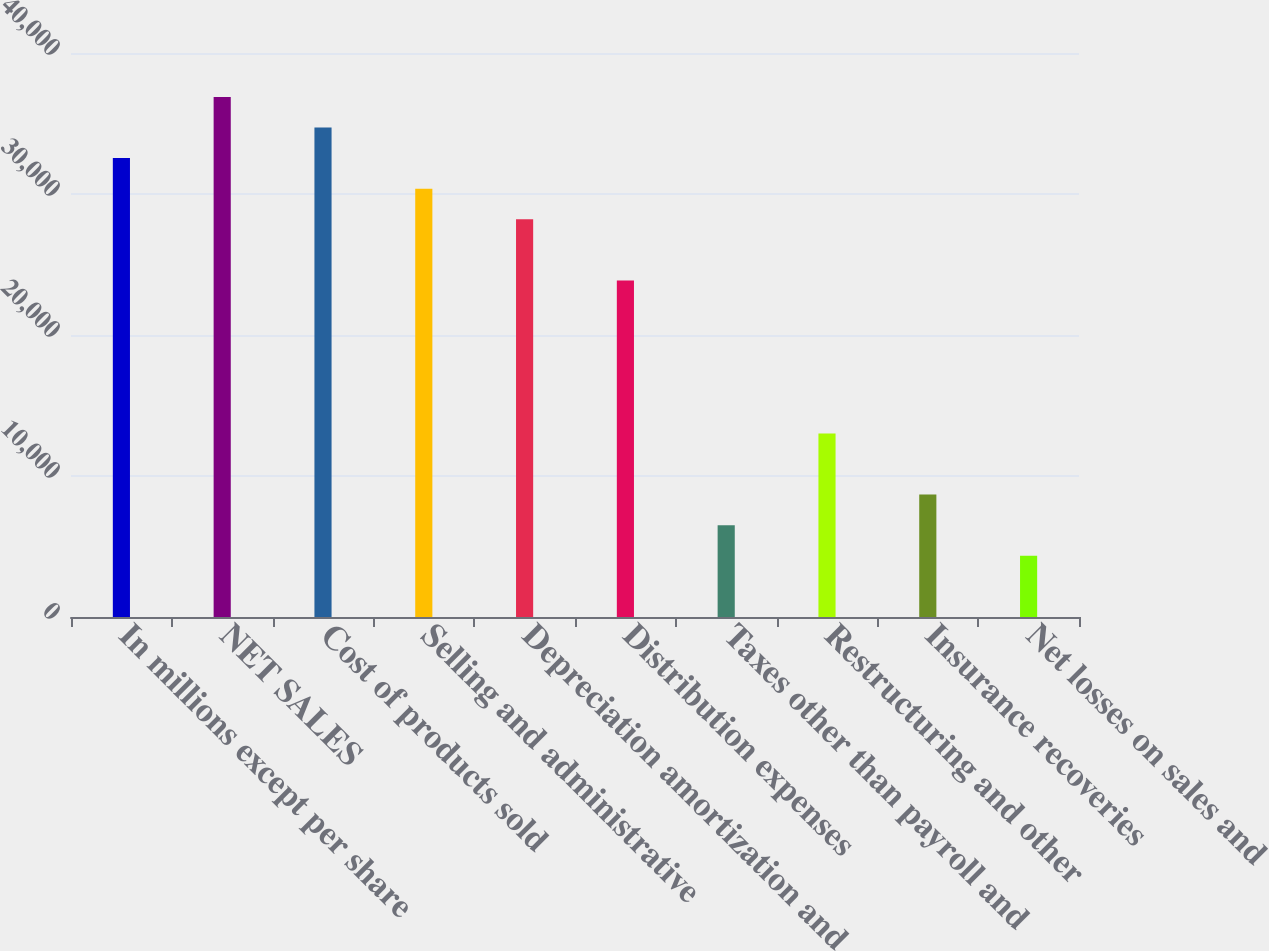Convert chart. <chart><loc_0><loc_0><loc_500><loc_500><bar_chart><fcel>In millions except per share<fcel>NET SALES<fcel>Cost of products sold<fcel>Selling and administrative<fcel>Depreciation amortization and<fcel>Distribution expenses<fcel>Taxes other than payroll and<fcel>Restructuring and other<fcel>Insurance recoveries<fcel>Net losses on sales and<nl><fcel>32548<fcel>36887.2<fcel>34717.6<fcel>30378.4<fcel>28208.8<fcel>23869.6<fcel>6512.8<fcel>13021.6<fcel>8682.4<fcel>4343.2<nl></chart> 